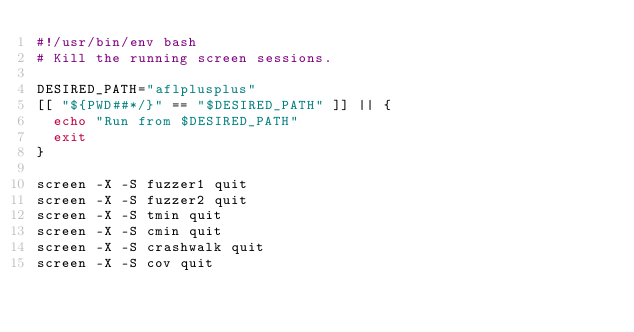<code> <loc_0><loc_0><loc_500><loc_500><_Bash_>#!/usr/bin/env bash
# Kill the running screen sessions.

DESIRED_PATH="aflplusplus"
[[ "${PWD##*/}" == "$DESIRED_PATH" ]] || {
  echo "Run from $DESIRED_PATH"
  exit
}

screen -X -S fuzzer1 quit
screen -X -S fuzzer2 quit
screen -X -S tmin quit
screen -X -S cmin quit
screen -X -S crashwalk quit
screen -X -S cov quit
</code> 